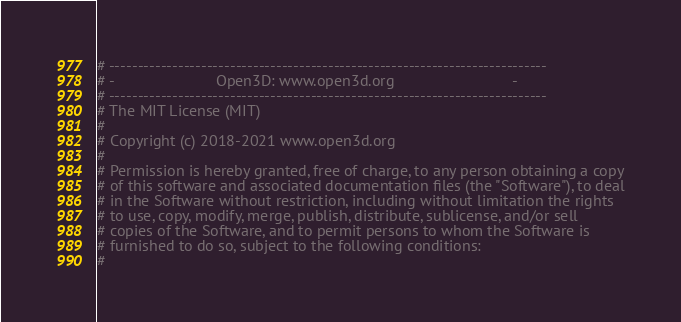<code> <loc_0><loc_0><loc_500><loc_500><_Python_># ----------------------------------------------------------------------------
# -                        Open3D: www.open3d.org                            -
# ----------------------------------------------------------------------------
# The MIT License (MIT)
#
# Copyright (c) 2018-2021 www.open3d.org
#
# Permission is hereby granted, free of charge, to any person obtaining a copy
# of this software and associated documentation files (the "Software"), to deal
# in the Software without restriction, including without limitation the rights
# to use, copy, modify, merge, publish, distribute, sublicense, and/or sell
# copies of the Software, and to permit persons to whom the Software is
# furnished to do so, subject to the following conditions:
#</code> 